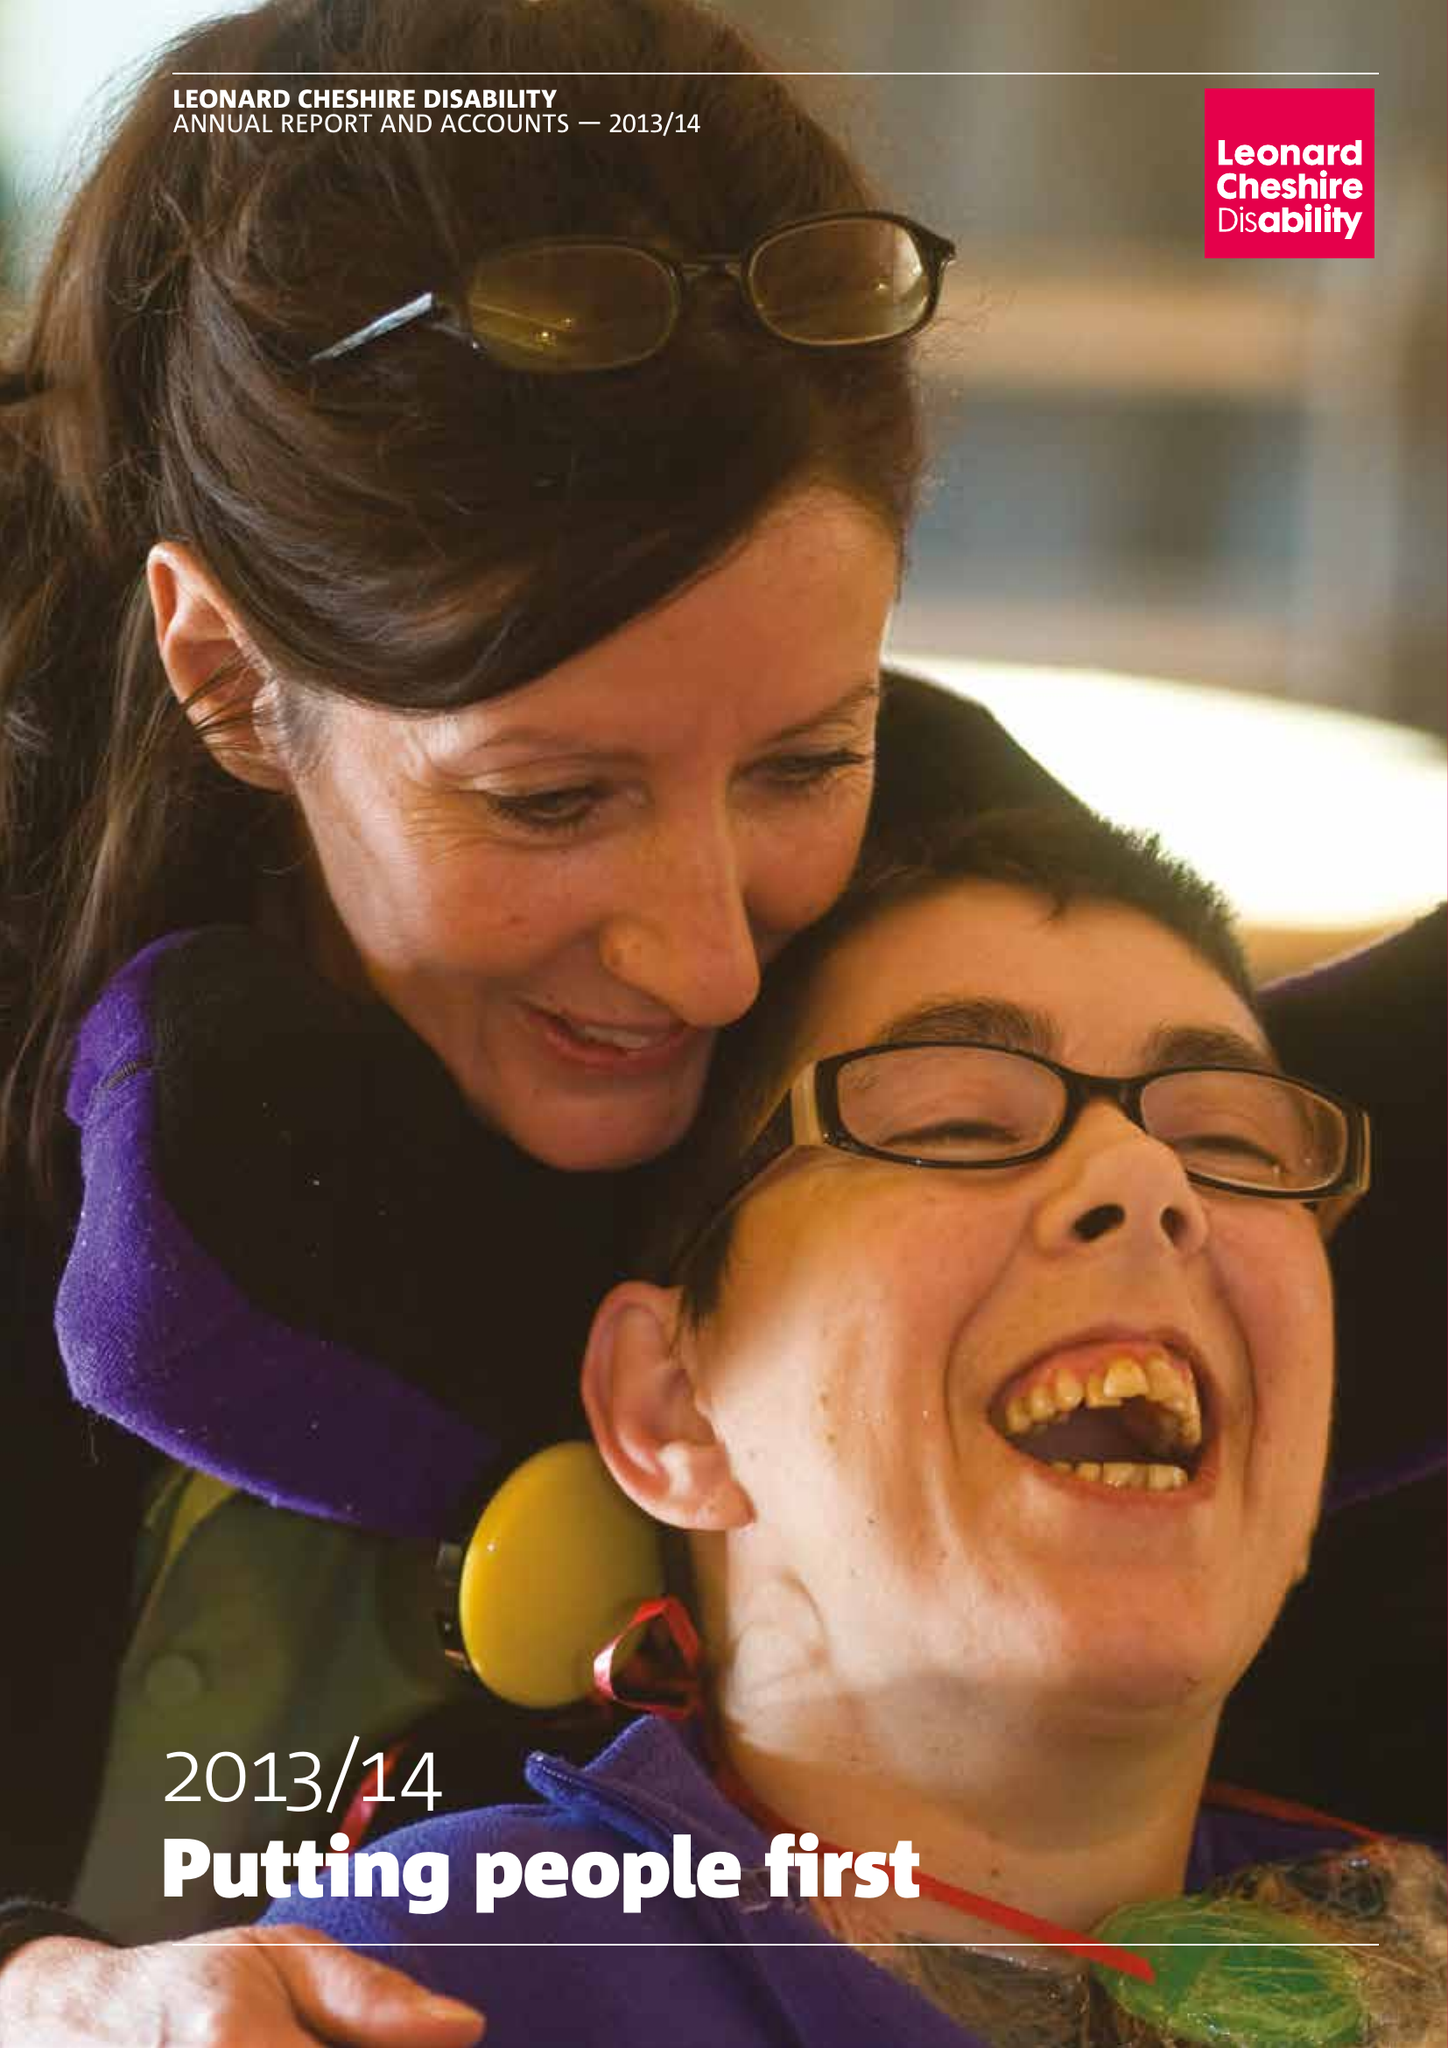What is the value for the address__street_line?
Answer the question using a single word or phrase. 66 SOUTH LAMBETH ROAD 